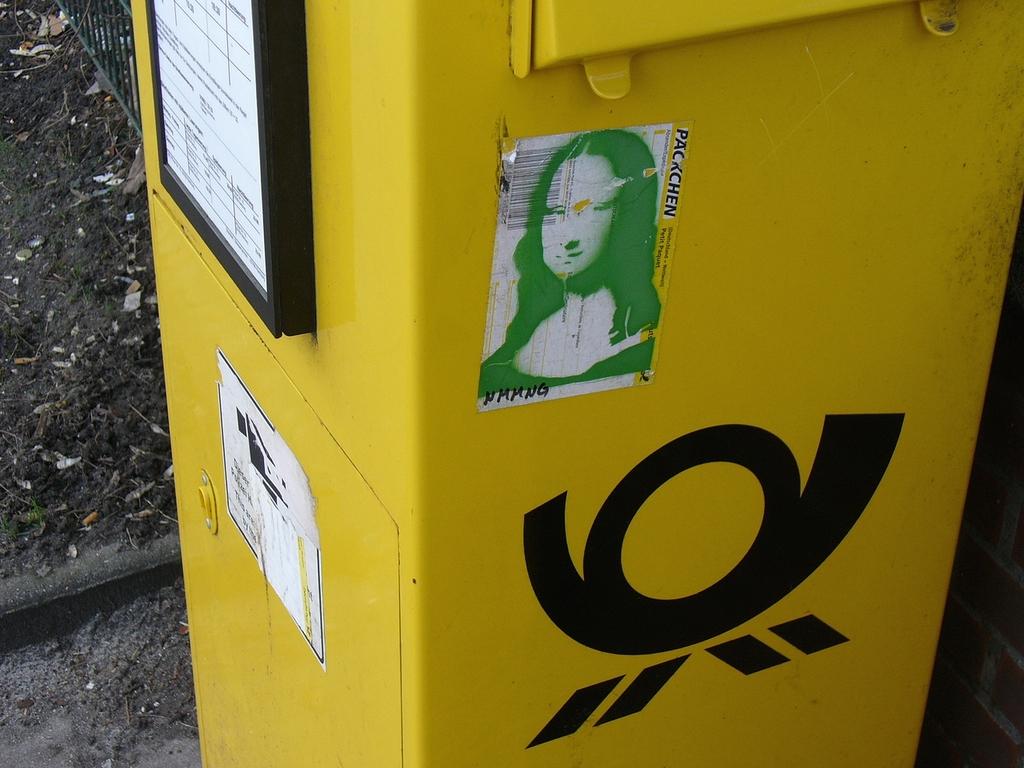What does the sticker say?
Your answer should be very brief. Packchen. 